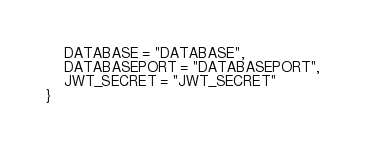<code> <loc_0><loc_0><loc_500><loc_500><_TypeScript_>    DATABASE = "DATABASE",
    DATABASEPORT = "DATABASEPORT",
    JWT_SECRET = "JWT_SECRET"
}</code> 